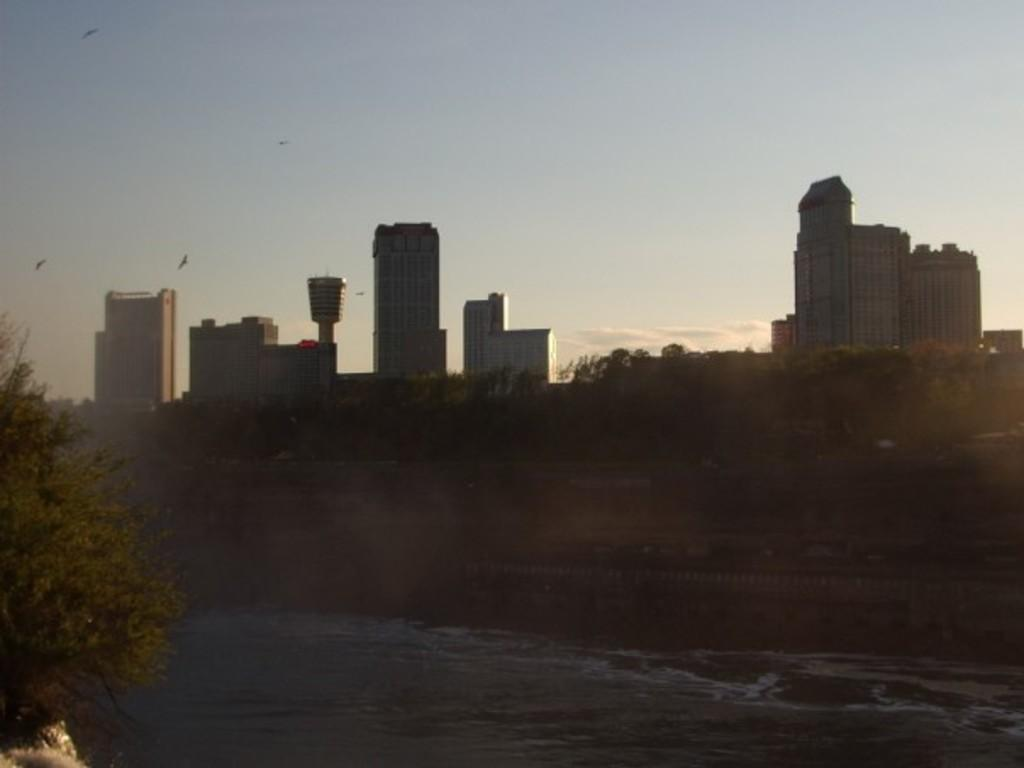What type of natural elements can be seen in the image? There are trees and water visible in the image. What type of man-made structures are present in the image? There are buildings in the image. What is happening in the sky in the image? Birds are flying in the image, and clouds are present in the sky. What is the background of the image? The sky is visible in the background of the image. What type of disease can be seen affecting the trees in the image? There is no indication of any disease affecting the trees in the image; they appear healthy. What level of water is present in the image? The image does not provide information about the level of water; it only shows that water is visible. 